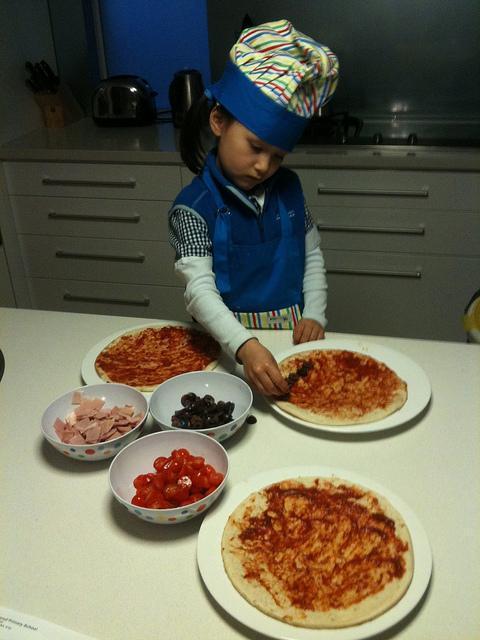How many bowls can be seen?
Give a very brief answer. 3. How many pizzas are visible?
Give a very brief answer. 3. How many giraffes are looking at the camera?
Give a very brief answer. 0. 